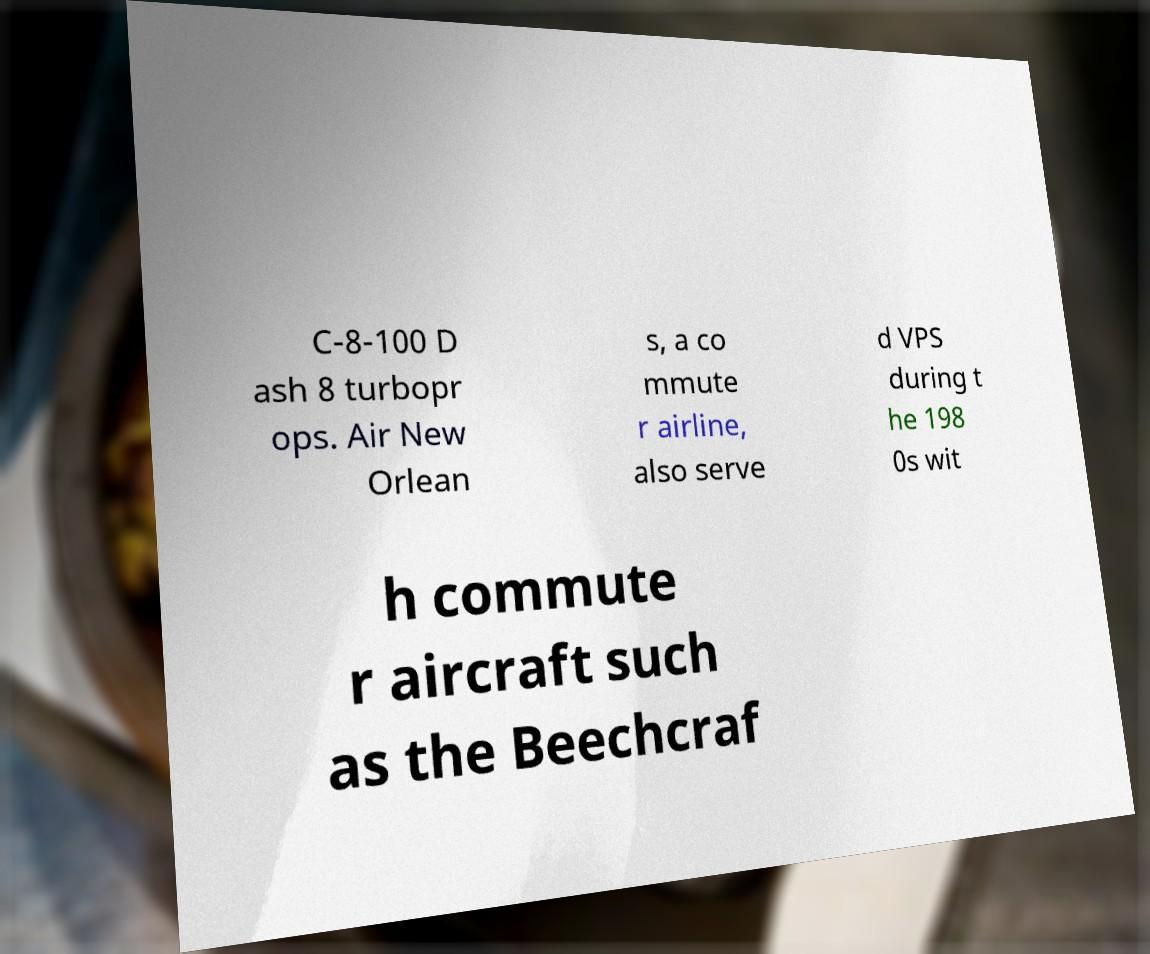What messages or text are displayed in this image? I need them in a readable, typed format. C-8-100 D ash 8 turbopr ops. Air New Orlean s, a co mmute r airline, also serve d VPS during t he 198 0s wit h commute r aircraft such as the Beechcraf 